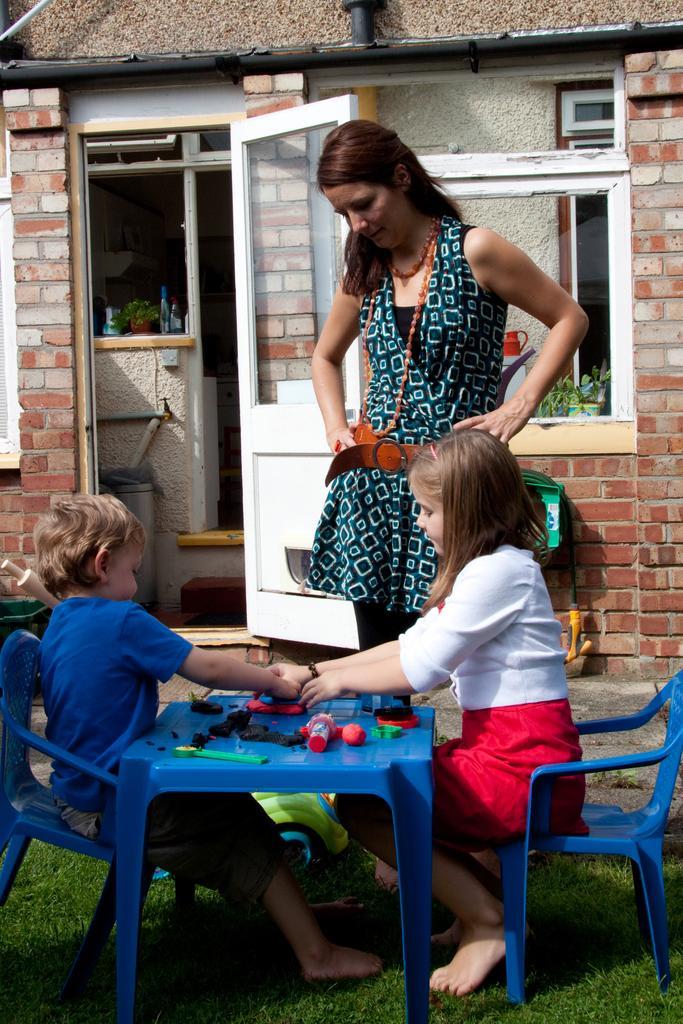Please provide a concise description of this image. This image is clicked outside the house. There are three people in this image. To are sitting and one person is standing. In the front, there is a table, on which some toys are kept. To the right, the girl is wearing white shirt and red skirt. To the left, the boy is wearing blue t-shirt. In the background, there is a house, door , window, and bricks wall. 